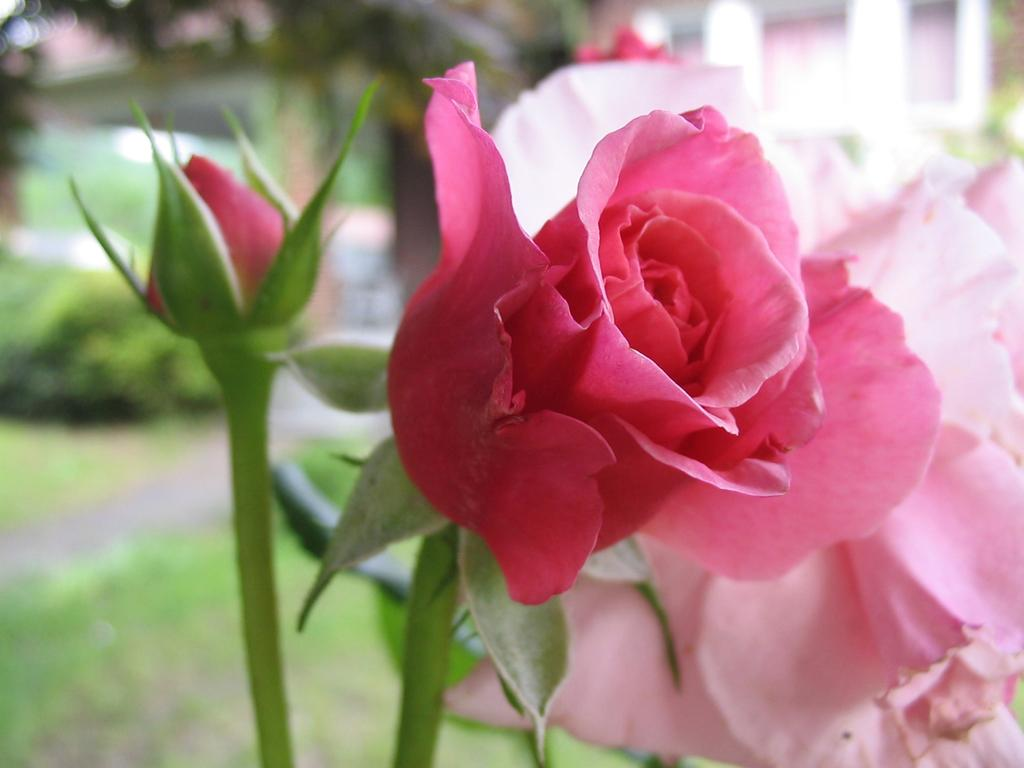What type of flowers are in the image? There are rose flowers in the image. What stage of growth are the roses in the image? There are rose buds in the image. What can be seen in the background of the image? There are trees, a building, and grass in the background of the image. How would you describe the overall quality of the image? The image is blurry. What riddle is written on the paper in the image? There is no paper or riddle present in the image. What type of feast is being prepared in the background of the image? There is no feast or preparation visible in the image; it only features rose flowers, rose buds, and the background elements. 